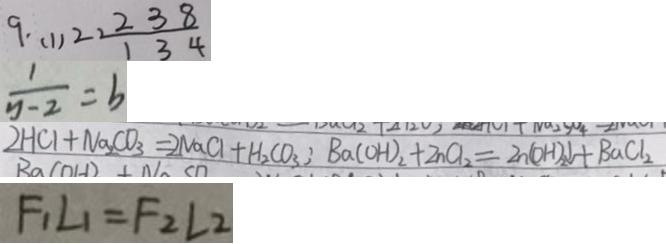<formula> <loc_0><loc_0><loc_500><loc_500>9 . ( 1 ) 2 2 \frac { 1 2 3 8 } { 1 3 4 } 
 \frac { 1 } { y - 2 } = b 
 2 H C l + N a _ { 2 } C O _ { 3 } = 2 N a C l + H _ { 2 } C O _ { 3 } ; B a ( O H ) _ { 2 } + Z n C l _ { 2 } = Z n ( O H ) _ { 2 } \downarrow + B a C l _ { 2 } 
 F _ { 1 } L _ { 1 } = F _ { 2 } L _ { 2 }</formula> 